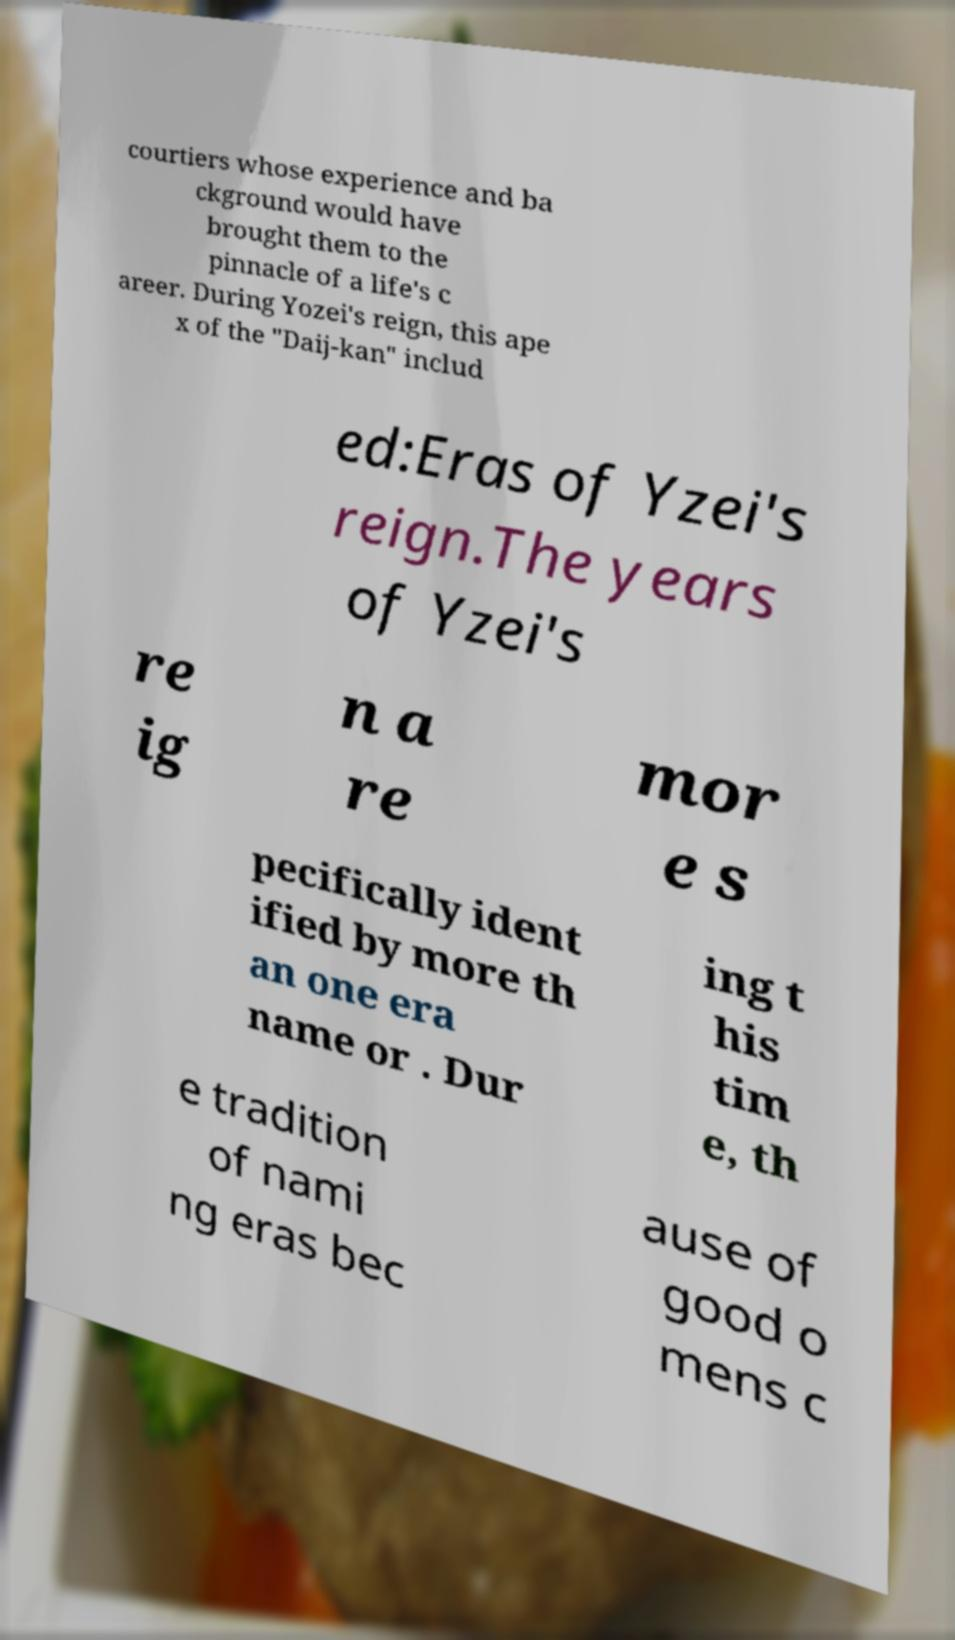There's text embedded in this image that I need extracted. Can you transcribe it verbatim? courtiers whose experience and ba ckground would have brought them to the pinnacle of a life's c areer. During Yozei's reign, this ape x of the "Daij-kan" includ ed:Eras of Yzei's reign.The years of Yzei's re ig n a re mor e s pecifically ident ified by more th an one era name or . Dur ing t his tim e, th e tradition of nami ng eras bec ause of good o mens c 